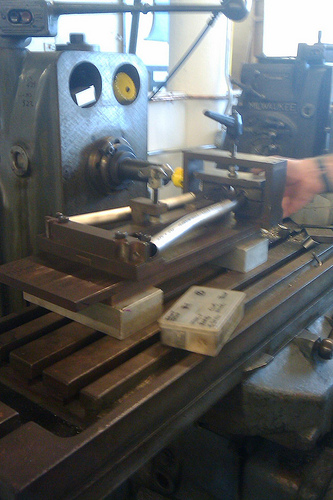<image>
Can you confirm if the drill is to the right of the bench? No. The drill is not to the right of the bench. The horizontal positioning shows a different relationship. 